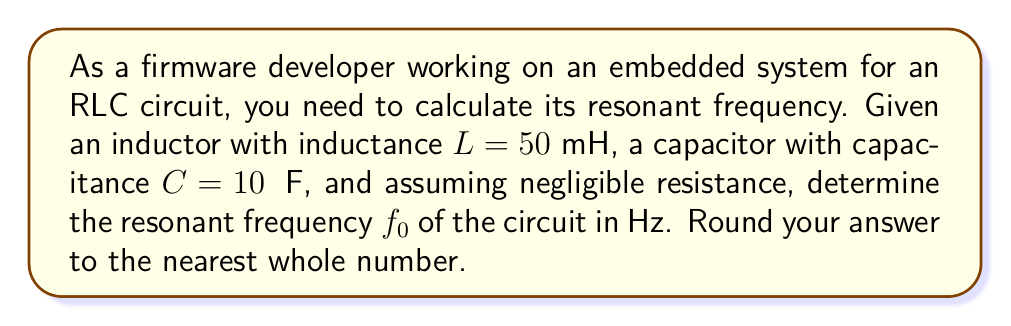Provide a solution to this math problem. To calculate the resonant frequency of an RLC circuit, we'll follow these steps:

1. Recall the formula for resonant frequency in an RLC circuit:

   $$f_0 = \frac{1}{2\pi\sqrt{LC}}$$

   Where:
   - $f_0$ is the resonant frequency in Hz
   - $L$ is the inductance in Henries (H)
   - $C$ is the capacitance in Farads (F)

2. Convert the given values to standard units:
   - $L = 50 \text{ mH} = 50 \times 10^{-3} \text{ H}$
   - $C = 10 \text{ μF} = 10 \times 10^{-6} \text{ F}$

3. Substitute these values into the formula:

   $$f_0 = \frac{1}{2\pi\sqrt{(50 \times 10^{-3})(10 \times 10^{-6})}}$$

4. Simplify under the square root:

   $$f_0 = \frac{1}{2\pi\sqrt{500 \times 10^{-9}}}$$

5. Calculate the value under the square root:

   $$f_0 = \frac{1}{2\pi\sqrt{5 \times 10^{-7}}}$$

6. Evaluate the square root:

   $$f_0 = \frac{1}{2\pi(7.0710678 \times 10^{-4})}$$

7. Complete the calculation:

   $$f_0 = 224.7208929 \text{ Hz}$$

8. Round to the nearest whole number:

   $$f_0 \approx 225 \text{ Hz}$$
Answer: 225 Hz 